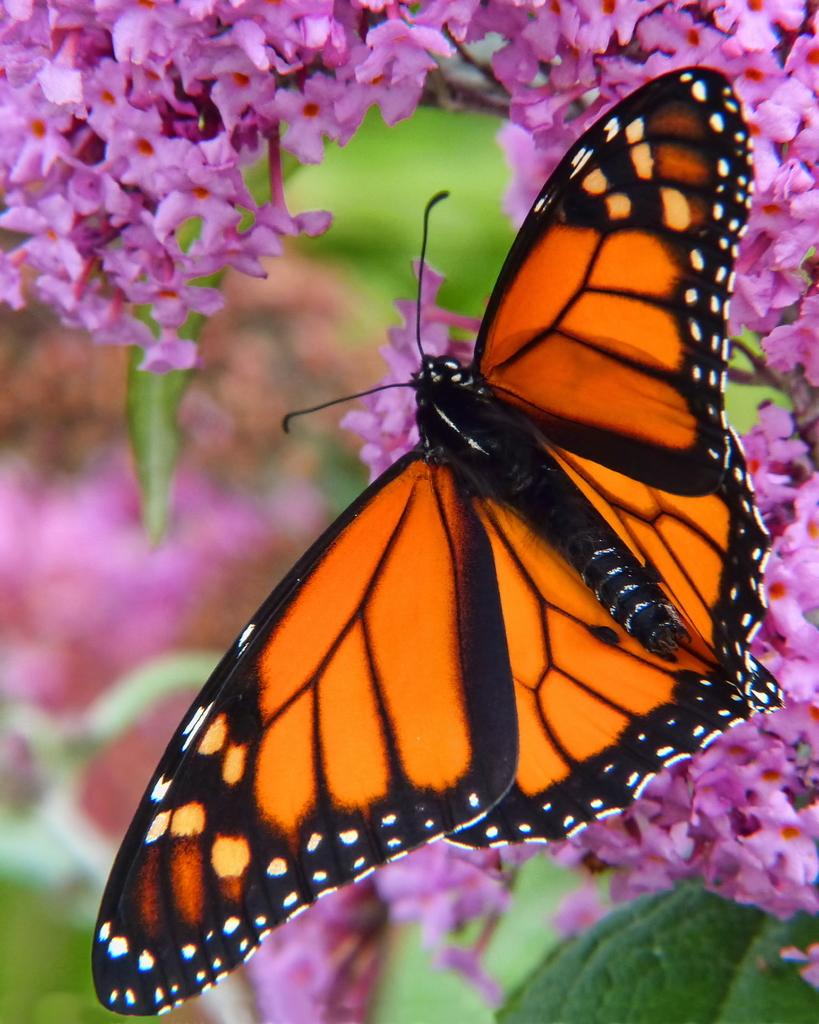What is the main subject of the image? There is a butterfly in the image. Where is the butterfly located? The butterfly is on flowers. Can you describe the background of the image? The background of the image is blurred. What type of train can be seen in the image? There is no train present in the image; it features a butterfly on flowers. How many tanks are visible in the image? There are no tanks present in the image. 